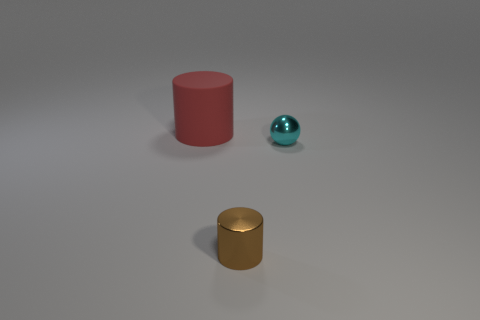Add 3 purple metallic spheres. How many objects exist? 6 Subtract all cylinders. How many objects are left? 1 Add 2 small gray rubber cylinders. How many small gray rubber cylinders exist? 2 Subtract 0 gray spheres. How many objects are left? 3 Subtract all tiny purple cylinders. Subtract all big things. How many objects are left? 2 Add 1 cyan metallic balls. How many cyan metallic balls are left? 2 